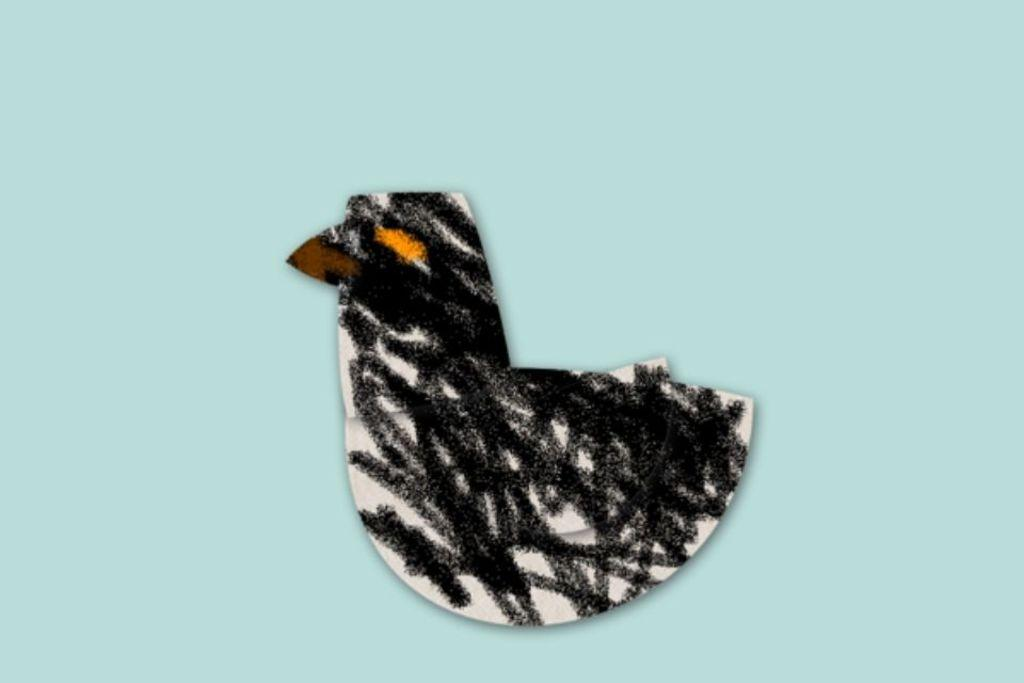What is the color of the surface in the image? The surface in the image is blue. What type of object can be seen on the surface? There is an object in the shape of a bird on the surface. Can you describe the colors of the bird-shaped object? The bird-shaped object has black, orange, brown, and white colors. What type of disease is affecting the bird-shaped object in the image? There is no indication of any disease affecting the bird-shaped object in the image. How does the bird-shaped object increase in size in the image? The bird-shaped object does not increase in size in the image; it is a static object with a fixed shape and size. 